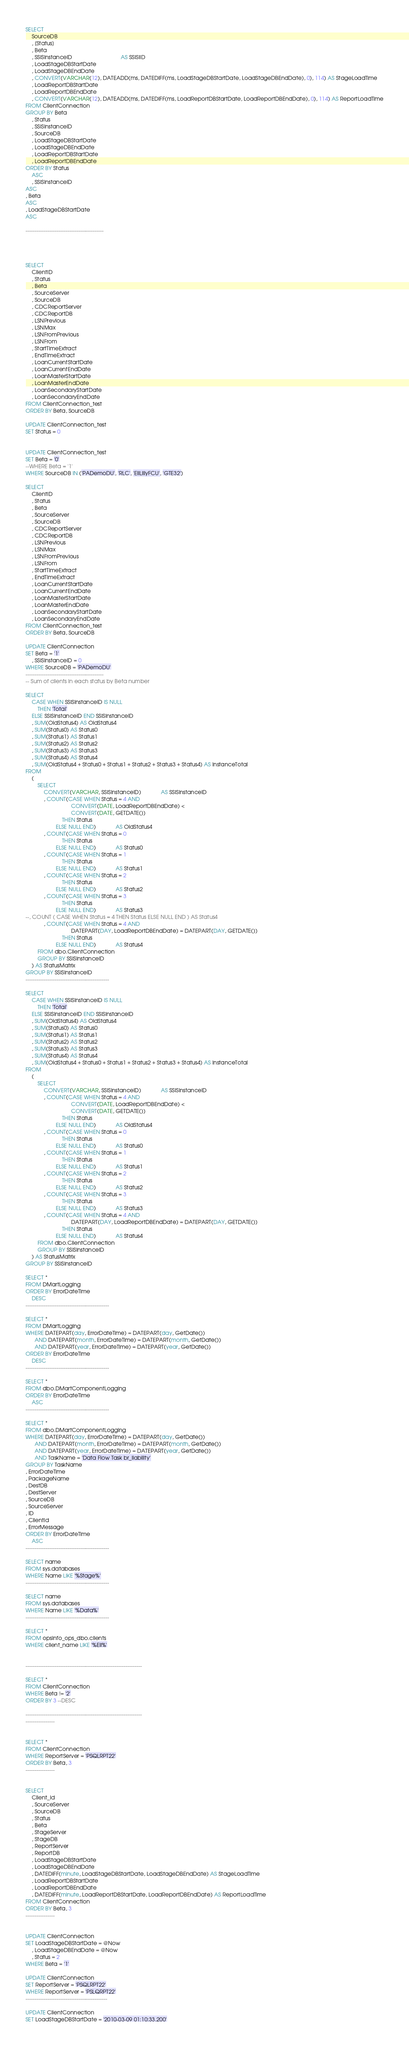<code> <loc_0><loc_0><loc_500><loc_500><_SQL_>SELECT
    SourceDB
    , [Status]
    , Beta
    , SSISInstanceID                                AS SSISIID
    , LoadStageDBStartDate
    , LoadStageDBEndDate
    , CONVERT(VARCHAR(12), DATEADD(ms, DATEDIFF(ms, LoadStageDBStartDate, LoadStageDBEndDate), 0), 114) AS StageLoadTime
    , LoadReportDBStartDate
    , LoadReportDBEndDate
    , CONVERT(VARCHAR(12), DATEADD(ms, DATEDIFF(ms, LoadReportDBStartDate, LoadReportDBEndDate), 0), 114) AS ReportLoadTime
FROM ClientConnection
GROUP BY Beta
    , Status
    , SSISInstanceID
    , SourceDB
    , LoadStageDBStartDate
    , LoadStageDBEndDate
    , LoadReportDBStartDate
    , LoadReportDBEndDate
ORDER BY Status
    ASC
    , SSISInstanceID
ASC
, Beta
ASC
, LoadStageDBStartDate
ASC

-------------------------------------------




SELECT
    ClientID
    , Status
    , Beta
    , SourceServer
    , SourceDB
    , CDCReportServer
    , CDCReportDB
    , LSNPrevious
    , LSNMax
    , LSNFromPrevious
    , LSNFrom
    , StartTimeExtract
    , EndTimeExtract
    , LoanCurrentStartDate
    , LoanCurrentEndDate
    , LoanMasterStartDate
    , LoanMasterEndDate
    , LoanSecondaryStartDate
    , LoanSecondaryEndDate
FROM ClientConnection_test
ORDER BY Beta, SourceDB

UPDATE ClientConnection_test
SET Status = 0


UPDATE ClientConnection_test
SET Beta = '0'
--WHERE Beta = '1'
WHERE SourceDB IN ('PADemoDU', 'RLC', 'EliLillyFCU', 'GTE32')

SELECT
    ClientID
    , Status
    , Beta
    , SourceServer
    , SourceDB
    , CDCReportServer
    , CDCReportDB
    , LSNPrevious
    , LSNMax
    , LSNFromPrevious
    , LSNFrom
    , StartTimeExtract
    , EndTimeExtract
    , LoanCurrentStartDate
    , LoanCurrentEndDate
    , LoanMasterStartDate
    , LoanMasterEndDate
    , LoanSecondaryStartDate
    , LoanSecondaryEndDate
FROM ClientConnection_test
ORDER BY Beta, SourceDB

UPDATE ClientConnection
SET Beta = '1'
    , SSISInstanceID = 0
WHERE SourceDB = 'PADemoDU'
-------------------------------------------
-- Sum of clients in each status by Beta number

SELECT
    CASE WHEN SSISInstanceID IS NULL
        THEN 'Total'
    ELSE SSISInstanceID END SSISInstanceID
    , SUM(OldStatus4) AS OldStatus4
    , SUM(Status0) AS Status0
    , SUM(Status1) AS Status1
    , SUM(Status2) AS Status2
    , SUM(Status3) AS Status3
    , SUM(Status4) AS Status4
    , SUM(OldStatus4 + Status0 + Status1 + Status2 + Status3 + Status4) AS InstanceTotal
FROM
    (
        SELECT
            CONVERT(VARCHAR, SSISInstanceID)             AS SSISInstanceID
            , COUNT(CASE WHEN Status = 4 AND
                              CONVERT(DATE, LoadReportDBEndDate) <
                              CONVERT(DATE, GETDATE())
                        THEN Status
                    ELSE NULL END)             AS OldStatus4
            , COUNT(CASE WHEN Status = 0
                        THEN Status
                    ELSE NULL END)             AS Status0
            , COUNT(CASE WHEN Status = 1
                        THEN Status
                    ELSE NULL END)             AS Status1
            , COUNT(CASE WHEN Status = 2
                        THEN Status
                    ELSE NULL END)             AS Status2
            , COUNT(CASE WHEN Status = 3
                        THEN Status
                    ELSE NULL END)             AS Status3
--, COUNT ( CASE WHEN Status = 4 THEN Status ELSE NULL END ) AS Status4
            , COUNT(CASE WHEN Status = 4 AND
                              DATEPART(DAY, LoadReportDBEndDate) = DATEPART(DAY, GETDATE())
                        THEN Status
                    ELSE NULL END)             AS Status4
        FROM dbo.ClientConnection
        GROUP BY SSISInstanceID
    ) AS StatusMatrix
GROUP BY SSISInstanceID
----------------------------------------------

SELECT
    CASE WHEN SSISInstanceID IS NULL
        THEN 'Total'
    ELSE SSISInstanceID END SSISInstanceID
    , SUM(OldStatus4) AS OldStatus4
    , SUM(Status0) AS Status0
    , SUM(Status1) AS Status1
    , SUM(Status2) AS Status2
    , SUM(Status3) AS Status3
    , SUM(Status4) AS Status4
    , SUM(OldStatus4 + Status0 + Status1 + Status2 + Status3 + Status4) AS InstanceTotal
FROM
    (
        SELECT
            CONVERT(VARCHAR, SSISInstanceID)             AS SSISInstanceID
            , COUNT(CASE WHEN Status = 4 AND
                              CONVERT(DATE, LoadReportDBEndDate) <
                              CONVERT(DATE, GETDATE())
                        THEN Status
                    ELSE NULL END)             AS OldStatus4
            , COUNT(CASE WHEN Status = 0
                        THEN Status
                    ELSE NULL END)             AS Status0
            , COUNT(CASE WHEN Status = 1
                        THEN Status
                    ELSE NULL END)             AS Status1
            , COUNT(CASE WHEN Status = 2
                        THEN Status
                    ELSE NULL END)             AS Status2
            , COUNT(CASE WHEN Status = 3
                        THEN Status
                    ELSE NULL END)             AS Status3
            , COUNT(CASE WHEN Status = 4 AND
                              DATEPART(DAY, LoadReportDBEndDate) = DATEPART(DAY, GETDATE())
                        THEN Status
                    ELSE NULL END)             AS Status4
        FROM dbo.ClientConnection
        GROUP BY SSISInstanceID
    ) AS StatusMatrix
GROUP BY SSISInstanceID

SELECT *
FROM DMartLogging
ORDER BY ErrorDateTime
    DESC
----------------------------------------------

SELECT *
FROM DMartLogging
WHERE DATEPART(day, ErrorDateTime) = DATEPART(day, GetDate())
      AND DATEPART(month, ErrorDateTime) = DATEPART(month, GetDate())
      AND DATEPART(year, ErrorDateTime) = DATEPART(year, GetDate())
ORDER BY ErrorDateTime
    DESC
----------------------------------------------

SELECT *
FROM dbo.DMartComponentLogging
ORDER BY ErrorDateTime
    ASC
----------------------------------------------

SELECT *
FROM dbo.DMartComponentLogging
WHERE DATEPART(day, ErrorDateTime) = DATEPART(day, GetDate())
      AND DATEPART(month, ErrorDateTime) = DATEPART(month, GetDate())
      AND DATEPART(year, ErrorDateTime) = DATEPART(year, GetDate())
      AND TaskName = 'Data Flow Task br_liability'
GROUP BY TaskName
, ErrorDateTime
, PackageName
, DestDB
, DestServer
, SourceDB
, SourceServer
, ID
, ClientId
, ErrorMessage
ORDER BY ErrorDateTime
    ASC
----------------------------------------------

SELECT name
FROM sys.databases
WHERE Name LIKE '%Stage%'
----------------------------------------------

SELECT name
FROM sys.databases
WHERE Name LIKE '%Data%'
----------------------------------------------

SELECT *
FROM opsinfo_ops_dbo.clients
WHERE client_name LIKE '%Eli%'


----------------------------------------------------------------

SELECT *
FROM ClientConnection
WHERE Beta != '2'
ORDER BY 3 --DESC

----------------------------------------------------------------
----------------


SELECT *
FROM ClientConnection
WHERE ReportServer = 'PSQLRPT22'
ORDER BY Beta, 3
----------------


SELECT
    Client_id
    , SourceServer
    , SourceDB
    , Status
    , Beta
    , StageServer
    , StageDB
    , ReportServer
    , ReportDB
    , LoadStageDBStartDate
    , LoadStageDBEndDate
    , DATEDIFF(minute, LoadStageDBStartDate, LoadStageDBEndDate) AS StageLoadTime
    , LoadReportDBStartDate
    , LoadReportDBEndDate
    , DATEDIFF(minute, LoadReportDBStartDate, LoadReportDBEndDate) AS ReportLoadTime
FROM ClientConnection
ORDER BY Beta, 3
----------------


UPDATE ClientConnection
SET LoadStageDBStartDate = @Now
    , LoadStageDBEndDate = @Now
    , Status = 2
WHERE Beta = '1'

UPDATE ClientConnection
SET ReportServer = 'PSQLRPT22'
WHERE ReportServer = 'PSLQRPT22'
---------------------------------------------

UPDATE ClientConnection
SET LoadStageDBStartDate = '2010-03-09 01:10:33.200'</code> 